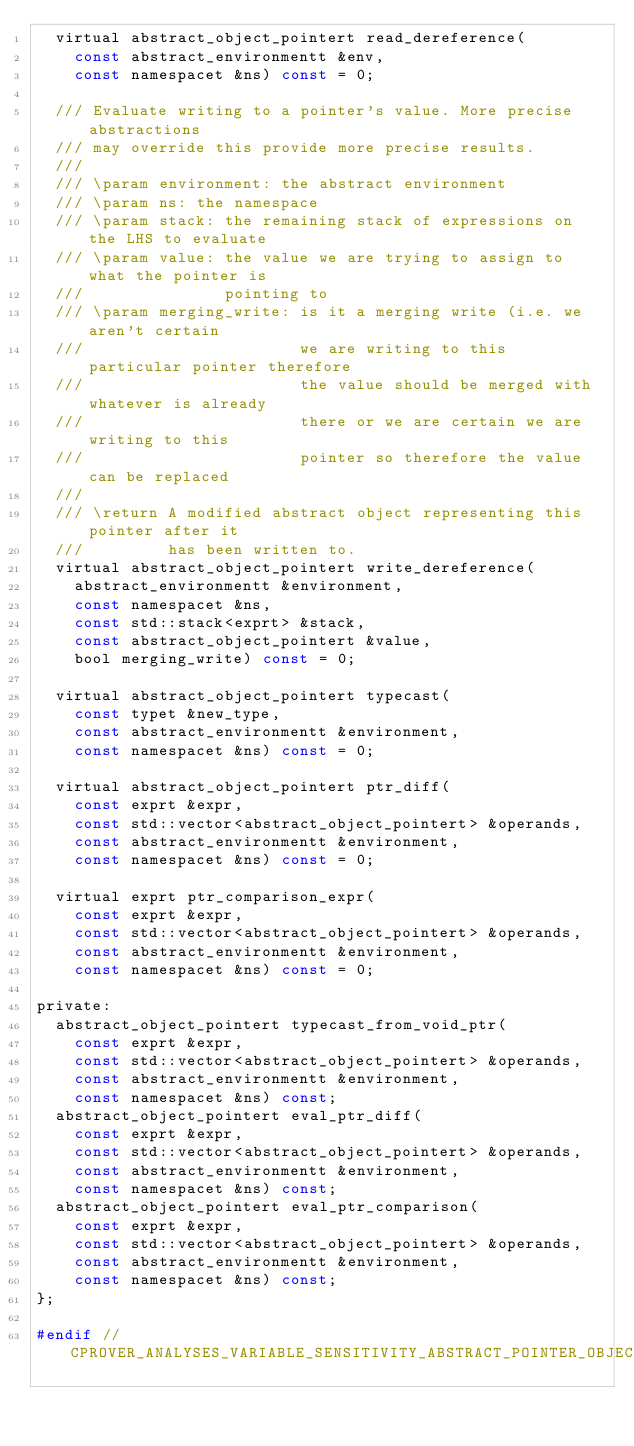<code> <loc_0><loc_0><loc_500><loc_500><_C_>  virtual abstract_object_pointert read_dereference(
    const abstract_environmentt &env,
    const namespacet &ns) const = 0;

  /// Evaluate writing to a pointer's value. More precise abstractions
  /// may override this provide more precise results.
  ///
  /// \param environment: the abstract environment
  /// \param ns: the namespace
  /// \param stack: the remaining stack of expressions on the LHS to evaluate
  /// \param value: the value we are trying to assign to what the pointer is
  ///               pointing to
  /// \param merging_write: is it a merging write (i.e. we aren't certain
  ///                       we are writing to this particular pointer therefore
  ///                       the value should be merged with whatever is already
  ///                       there or we are certain we are writing to this
  ///                       pointer so therefore the value can be replaced
  ///
  /// \return A modified abstract object representing this pointer after it
  ///         has been written to.
  virtual abstract_object_pointert write_dereference(
    abstract_environmentt &environment,
    const namespacet &ns,
    const std::stack<exprt> &stack,
    const abstract_object_pointert &value,
    bool merging_write) const = 0;

  virtual abstract_object_pointert typecast(
    const typet &new_type,
    const abstract_environmentt &environment,
    const namespacet &ns) const = 0;

  virtual abstract_object_pointert ptr_diff(
    const exprt &expr,
    const std::vector<abstract_object_pointert> &operands,
    const abstract_environmentt &environment,
    const namespacet &ns) const = 0;

  virtual exprt ptr_comparison_expr(
    const exprt &expr,
    const std::vector<abstract_object_pointert> &operands,
    const abstract_environmentt &environment,
    const namespacet &ns) const = 0;

private:
  abstract_object_pointert typecast_from_void_ptr(
    const exprt &expr,
    const std::vector<abstract_object_pointert> &operands,
    const abstract_environmentt &environment,
    const namespacet &ns) const;
  abstract_object_pointert eval_ptr_diff(
    const exprt &expr,
    const std::vector<abstract_object_pointert> &operands,
    const abstract_environmentt &environment,
    const namespacet &ns) const;
  abstract_object_pointert eval_ptr_comparison(
    const exprt &expr,
    const std::vector<abstract_object_pointert> &operands,
    const abstract_environmentt &environment,
    const namespacet &ns) const;
};

#endif // CPROVER_ANALYSES_VARIABLE_SENSITIVITY_ABSTRACT_POINTER_OBJECT_H
</code> 